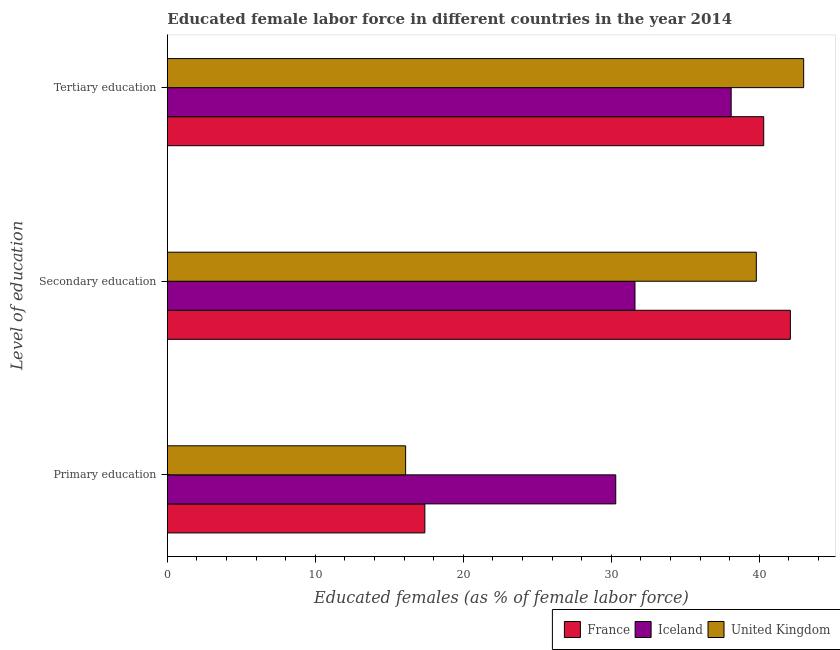How many groups of bars are there?
Provide a short and direct response. 3. Are the number of bars per tick equal to the number of legend labels?
Your response must be concise. Yes. How many bars are there on the 3rd tick from the top?
Your answer should be very brief. 3. How many bars are there on the 3rd tick from the bottom?
Your answer should be compact. 3. What is the label of the 1st group of bars from the top?
Give a very brief answer. Tertiary education. What is the percentage of female labor force who received tertiary education in Iceland?
Keep it short and to the point. 38.1. Across all countries, what is the maximum percentage of female labor force who received primary education?
Keep it short and to the point. 30.3. Across all countries, what is the minimum percentage of female labor force who received tertiary education?
Your response must be concise. 38.1. In which country was the percentage of female labor force who received primary education maximum?
Give a very brief answer. Iceland. What is the total percentage of female labor force who received primary education in the graph?
Give a very brief answer. 63.8. What is the difference between the percentage of female labor force who received primary education in Iceland and that in United Kingdom?
Provide a succinct answer. 14.2. What is the difference between the percentage of female labor force who received tertiary education in United Kingdom and the percentage of female labor force who received secondary education in Iceland?
Your response must be concise. 11.4. What is the average percentage of female labor force who received tertiary education per country?
Give a very brief answer. 40.47. What is the difference between the percentage of female labor force who received tertiary education and percentage of female labor force who received primary education in United Kingdom?
Offer a very short reply. 26.9. What is the ratio of the percentage of female labor force who received tertiary education in United Kingdom to that in France?
Your response must be concise. 1.07. Is the difference between the percentage of female labor force who received secondary education in United Kingdom and France greater than the difference between the percentage of female labor force who received tertiary education in United Kingdom and France?
Offer a terse response. No. What is the difference between the highest and the second highest percentage of female labor force who received primary education?
Ensure brevity in your answer.  12.9. What is the difference between the highest and the lowest percentage of female labor force who received primary education?
Keep it short and to the point. 14.2. What does the 2nd bar from the top in Secondary education represents?
Give a very brief answer. Iceland. Is it the case that in every country, the sum of the percentage of female labor force who received primary education and percentage of female labor force who received secondary education is greater than the percentage of female labor force who received tertiary education?
Offer a very short reply. Yes. How many bars are there?
Provide a short and direct response. 9. Are all the bars in the graph horizontal?
Your answer should be very brief. Yes. Are the values on the major ticks of X-axis written in scientific E-notation?
Provide a short and direct response. No. Does the graph contain grids?
Provide a short and direct response. No. Where does the legend appear in the graph?
Your response must be concise. Bottom right. How many legend labels are there?
Make the answer very short. 3. How are the legend labels stacked?
Offer a very short reply. Horizontal. What is the title of the graph?
Make the answer very short. Educated female labor force in different countries in the year 2014. Does "Singapore" appear as one of the legend labels in the graph?
Ensure brevity in your answer.  No. What is the label or title of the X-axis?
Ensure brevity in your answer.  Educated females (as % of female labor force). What is the label or title of the Y-axis?
Keep it short and to the point. Level of education. What is the Educated females (as % of female labor force) in France in Primary education?
Make the answer very short. 17.4. What is the Educated females (as % of female labor force) in Iceland in Primary education?
Your answer should be compact. 30.3. What is the Educated females (as % of female labor force) of United Kingdom in Primary education?
Provide a succinct answer. 16.1. What is the Educated females (as % of female labor force) of France in Secondary education?
Ensure brevity in your answer.  42.1. What is the Educated females (as % of female labor force) of Iceland in Secondary education?
Your answer should be very brief. 31.6. What is the Educated females (as % of female labor force) in United Kingdom in Secondary education?
Your answer should be very brief. 39.8. What is the Educated females (as % of female labor force) in France in Tertiary education?
Offer a terse response. 40.3. What is the Educated females (as % of female labor force) of Iceland in Tertiary education?
Your answer should be compact. 38.1. What is the Educated females (as % of female labor force) in United Kingdom in Tertiary education?
Your answer should be very brief. 43. Across all Level of education, what is the maximum Educated females (as % of female labor force) in France?
Your answer should be compact. 42.1. Across all Level of education, what is the maximum Educated females (as % of female labor force) of Iceland?
Your answer should be compact. 38.1. Across all Level of education, what is the minimum Educated females (as % of female labor force) in France?
Give a very brief answer. 17.4. Across all Level of education, what is the minimum Educated females (as % of female labor force) in Iceland?
Offer a terse response. 30.3. Across all Level of education, what is the minimum Educated females (as % of female labor force) in United Kingdom?
Ensure brevity in your answer.  16.1. What is the total Educated females (as % of female labor force) of France in the graph?
Your answer should be very brief. 99.8. What is the total Educated females (as % of female labor force) in Iceland in the graph?
Give a very brief answer. 100. What is the total Educated females (as % of female labor force) of United Kingdom in the graph?
Make the answer very short. 98.9. What is the difference between the Educated females (as % of female labor force) in France in Primary education and that in Secondary education?
Give a very brief answer. -24.7. What is the difference between the Educated females (as % of female labor force) in United Kingdom in Primary education and that in Secondary education?
Provide a short and direct response. -23.7. What is the difference between the Educated females (as % of female labor force) in France in Primary education and that in Tertiary education?
Offer a terse response. -22.9. What is the difference between the Educated females (as % of female labor force) in United Kingdom in Primary education and that in Tertiary education?
Offer a very short reply. -26.9. What is the difference between the Educated females (as % of female labor force) of Iceland in Secondary education and that in Tertiary education?
Offer a very short reply. -6.5. What is the difference between the Educated females (as % of female labor force) in United Kingdom in Secondary education and that in Tertiary education?
Keep it short and to the point. -3.2. What is the difference between the Educated females (as % of female labor force) in France in Primary education and the Educated females (as % of female labor force) in United Kingdom in Secondary education?
Provide a succinct answer. -22.4. What is the difference between the Educated females (as % of female labor force) in Iceland in Primary education and the Educated females (as % of female labor force) in United Kingdom in Secondary education?
Give a very brief answer. -9.5. What is the difference between the Educated females (as % of female labor force) in France in Primary education and the Educated females (as % of female labor force) in Iceland in Tertiary education?
Offer a very short reply. -20.7. What is the difference between the Educated females (as % of female labor force) of France in Primary education and the Educated females (as % of female labor force) of United Kingdom in Tertiary education?
Make the answer very short. -25.6. What is the difference between the Educated females (as % of female labor force) of France in Secondary education and the Educated females (as % of female labor force) of United Kingdom in Tertiary education?
Give a very brief answer. -0.9. What is the average Educated females (as % of female labor force) of France per Level of education?
Offer a terse response. 33.27. What is the average Educated females (as % of female labor force) in Iceland per Level of education?
Provide a short and direct response. 33.33. What is the average Educated females (as % of female labor force) of United Kingdom per Level of education?
Provide a short and direct response. 32.97. What is the difference between the Educated females (as % of female labor force) in Iceland and Educated females (as % of female labor force) in United Kingdom in Primary education?
Your answer should be very brief. 14.2. What is the difference between the Educated females (as % of female labor force) of France and Educated females (as % of female labor force) of Iceland in Secondary education?
Your response must be concise. 10.5. What is the difference between the Educated females (as % of female labor force) in France and Educated females (as % of female labor force) in United Kingdom in Secondary education?
Give a very brief answer. 2.3. What is the difference between the Educated females (as % of female labor force) in France and Educated females (as % of female labor force) in Iceland in Tertiary education?
Provide a succinct answer. 2.2. What is the difference between the Educated females (as % of female labor force) of France and Educated females (as % of female labor force) of United Kingdom in Tertiary education?
Your answer should be very brief. -2.7. What is the ratio of the Educated females (as % of female labor force) of France in Primary education to that in Secondary education?
Keep it short and to the point. 0.41. What is the ratio of the Educated females (as % of female labor force) in Iceland in Primary education to that in Secondary education?
Provide a succinct answer. 0.96. What is the ratio of the Educated females (as % of female labor force) of United Kingdom in Primary education to that in Secondary education?
Keep it short and to the point. 0.4. What is the ratio of the Educated females (as % of female labor force) in France in Primary education to that in Tertiary education?
Provide a succinct answer. 0.43. What is the ratio of the Educated females (as % of female labor force) of Iceland in Primary education to that in Tertiary education?
Provide a succinct answer. 0.8. What is the ratio of the Educated females (as % of female labor force) in United Kingdom in Primary education to that in Tertiary education?
Your answer should be compact. 0.37. What is the ratio of the Educated females (as % of female labor force) of France in Secondary education to that in Tertiary education?
Provide a short and direct response. 1.04. What is the ratio of the Educated females (as % of female labor force) of Iceland in Secondary education to that in Tertiary education?
Ensure brevity in your answer.  0.83. What is the ratio of the Educated females (as % of female labor force) in United Kingdom in Secondary education to that in Tertiary education?
Give a very brief answer. 0.93. What is the difference between the highest and the second highest Educated females (as % of female labor force) in France?
Make the answer very short. 1.8. What is the difference between the highest and the second highest Educated females (as % of female labor force) of United Kingdom?
Make the answer very short. 3.2. What is the difference between the highest and the lowest Educated females (as % of female labor force) in France?
Provide a succinct answer. 24.7. What is the difference between the highest and the lowest Educated females (as % of female labor force) in United Kingdom?
Your answer should be compact. 26.9. 